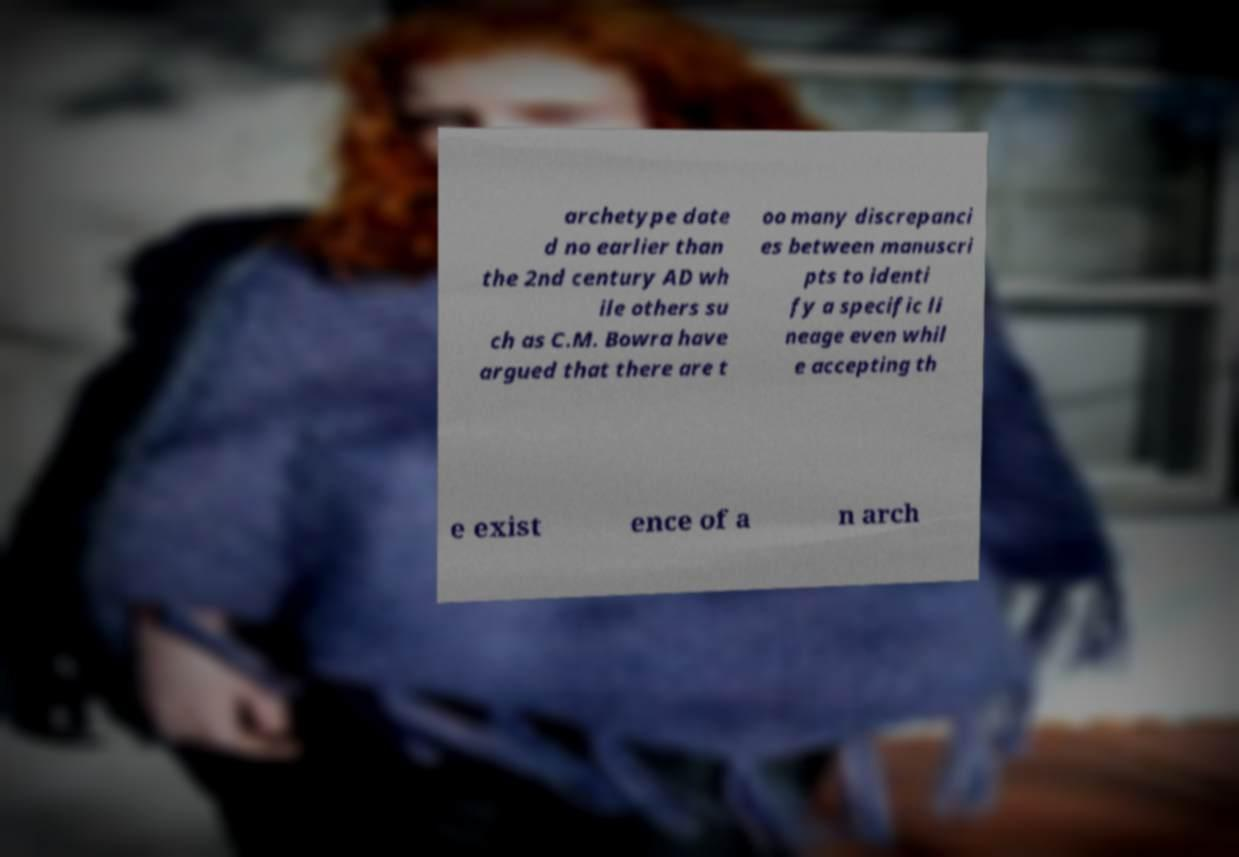Please identify and transcribe the text found in this image. archetype date d no earlier than the 2nd century AD wh ile others su ch as C.M. Bowra have argued that there are t oo many discrepanci es between manuscri pts to identi fy a specific li neage even whil e accepting th e exist ence of a n arch 